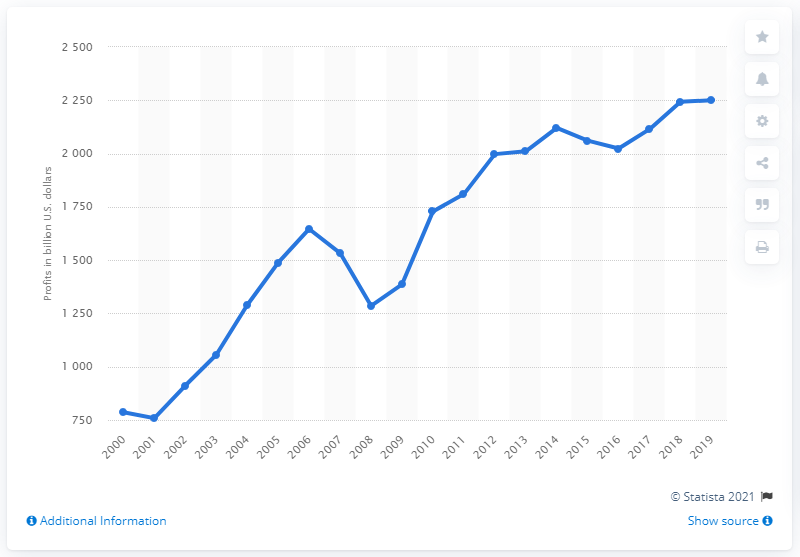Draw attention to some important aspects in this diagram. In 2019, corporations in the United States earned a total of $2,250.5 billion in revenue. 